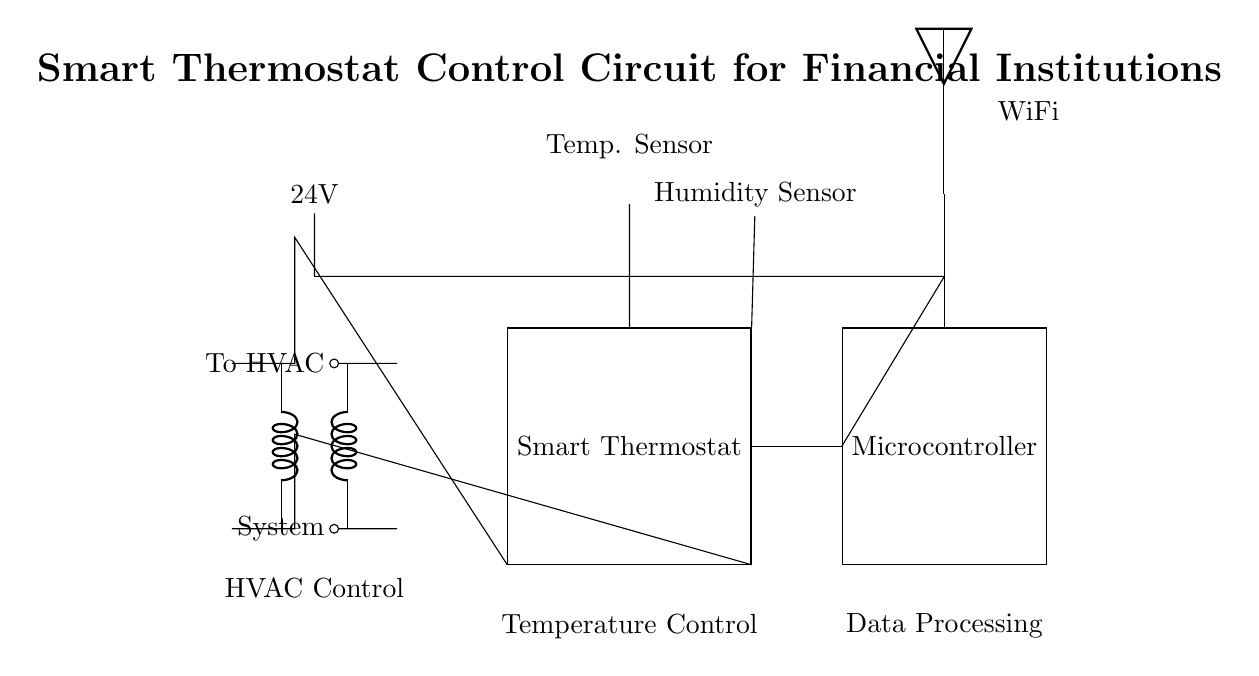What is the primary function of the smart thermostat? The primary function of the smart thermostat is to control the temperature in the HVAC system, allowing for temperature regulation based on set parameters.
Answer: Temperature Control What voltage does the power supply provide? The power supply in the circuit is labeled as 24V, which indicates that it supplies a potential difference of 24 volts to the system.
Answer: 24V How many sensors are present in this circuit? There are two sensors present in the circuit: a temperature sensor and a humidity sensor, as indicated by the components connected to the smart thermostat.
Answer: Two Which component is responsible for data processing? The microcontroller is responsible for data processing in the circuit, as indicated by its label and positioning in relation to other components.
Answer: Microcontroller What type of sensor is used to measure temperature? A thermistor is used to measure temperature in the circuit, as indicated by the label next to the specific component.
Answer: Thermistor Explain the connection between the HVAC system and the smart thermostat. The HVAC system is connected to the smart thermostat through two wires that carry signals from the HVAC system, which is indicated by the lines drawn from the transformer to the thermostat. These connections determine how the HVAC responds to temperature changes detected by the thermostat.
Answer: HVAC to Smart Thermostat What is the purpose of the WiFi module in the circuit? The WiFi module facilitates remote control and monitoring functions for the thermostat, enabling the system to connect to the internet. This function is implied by the presence of the antenna connected to the microcontroller.
Answer: Remote control 